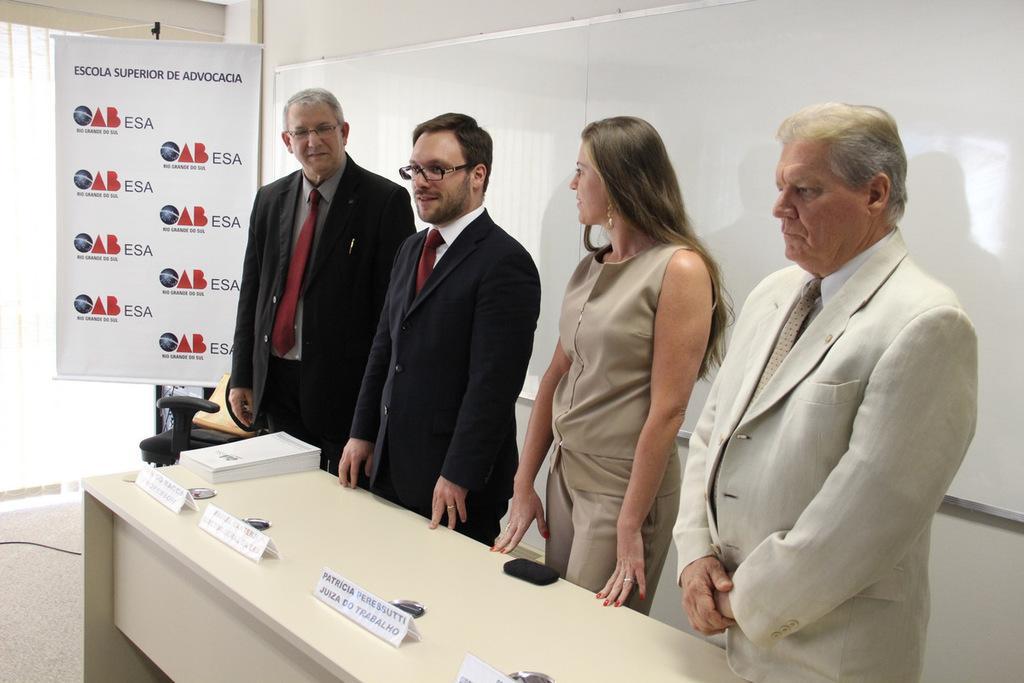In one or two sentences, can you explain what this image depicts? In the picture I can see a person wearing white color blazer and these two men wearing black color blazers and a woman standing here. Here we can see name boards and some papers are placed on the table. In the background, I can see a board, banner and windows. 